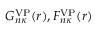Convert formula to latex. <formula><loc_0><loc_0><loc_500><loc_500>G _ { n \kappa } ^ { V P } ( r ) , F _ { n \kappa } ^ { V P } ( r )</formula> 